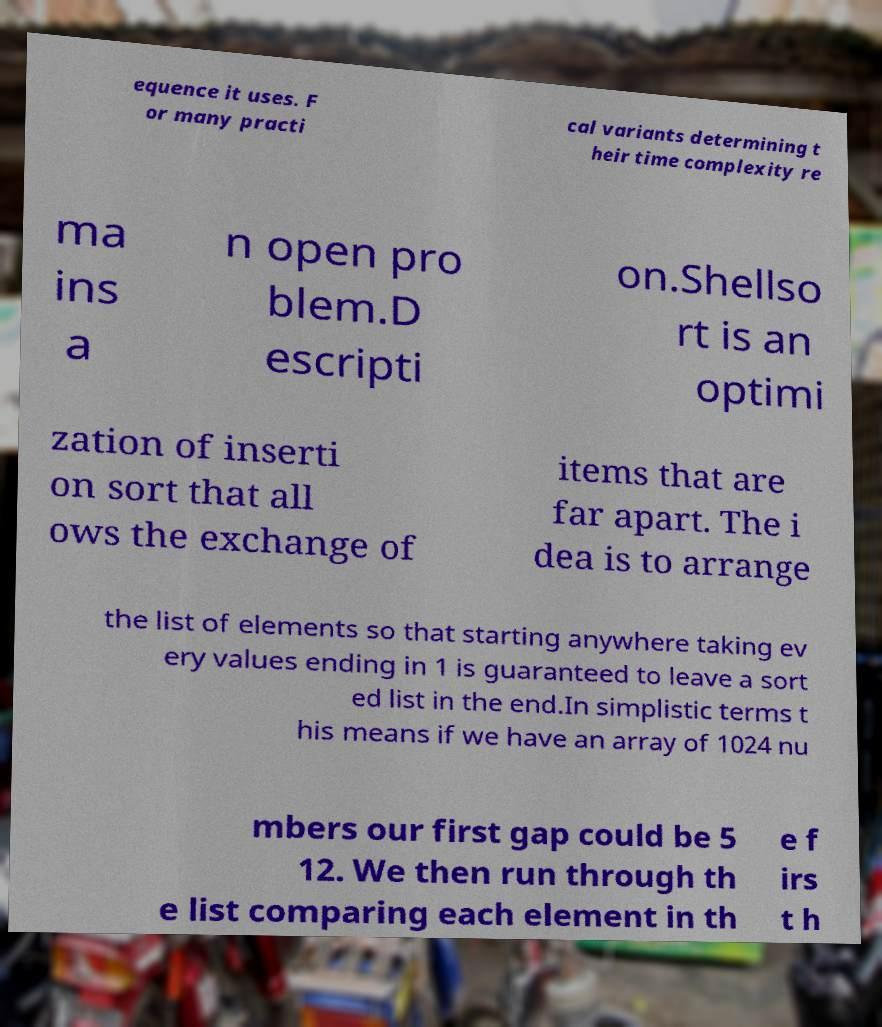What messages or text are displayed in this image? I need them in a readable, typed format. equence it uses. F or many practi cal variants determining t heir time complexity re ma ins a n open pro blem.D escripti on.Shellso rt is an optimi zation of inserti on sort that all ows the exchange of items that are far apart. The i dea is to arrange the list of elements so that starting anywhere taking ev ery values ending in 1 is guaranteed to leave a sort ed list in the end.In simplistic terms t his means if we have an array of 1024 nu mbers our first gap could be 5 12. We then run through th e list comparing each element in th e f irs t h 